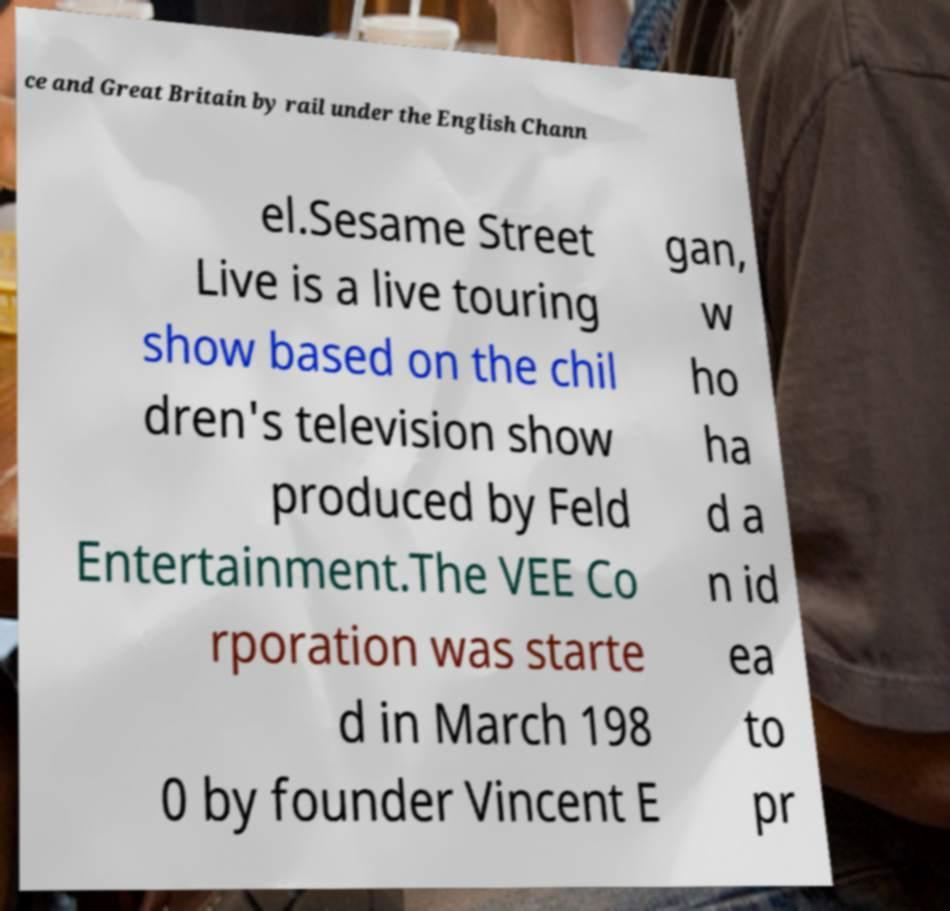I need the written content from this picture converted into text. Can you do that? ce and Great Britain by rail under the English Chann el.Sesame Street Live is a live touring show based on the chil dren's television show produced by Feld Entertainment.The VEE Co rporation was starte d in March 198 0 by founder Vincent E gan, w ho ha d a n id ea to pr 